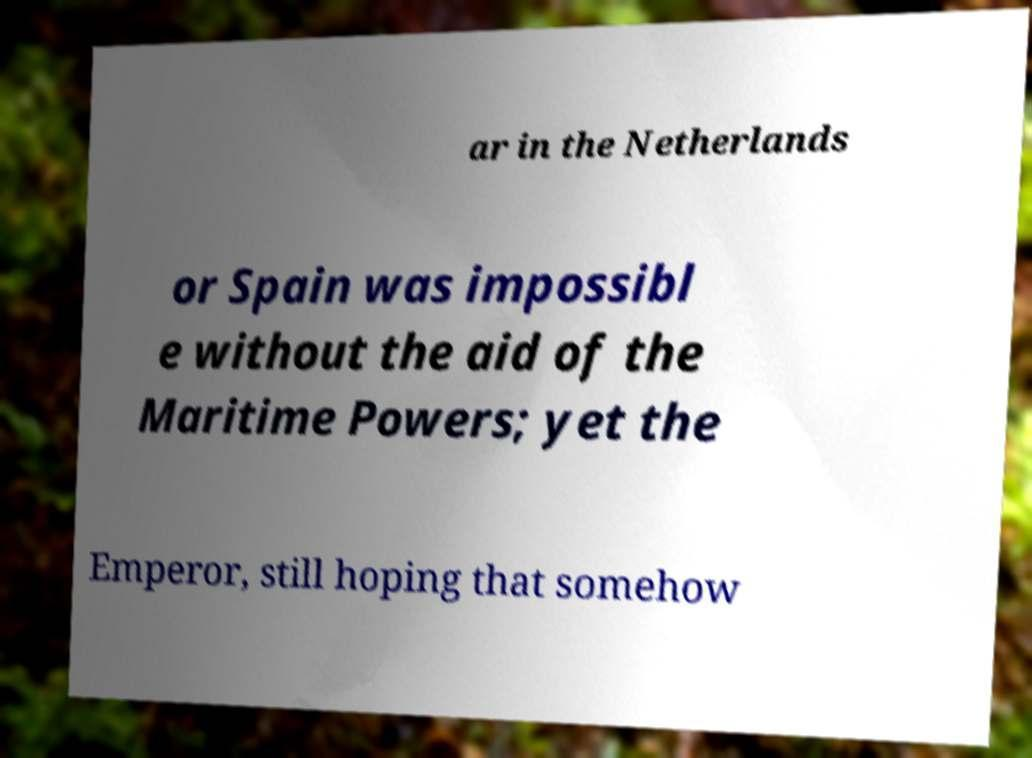Please identify and transcribe the text found in this image. ar in the Netherlands or Spain was impossibl e without the aid of the Maritime Powers; yet the Emperor, still hoping that somehow 